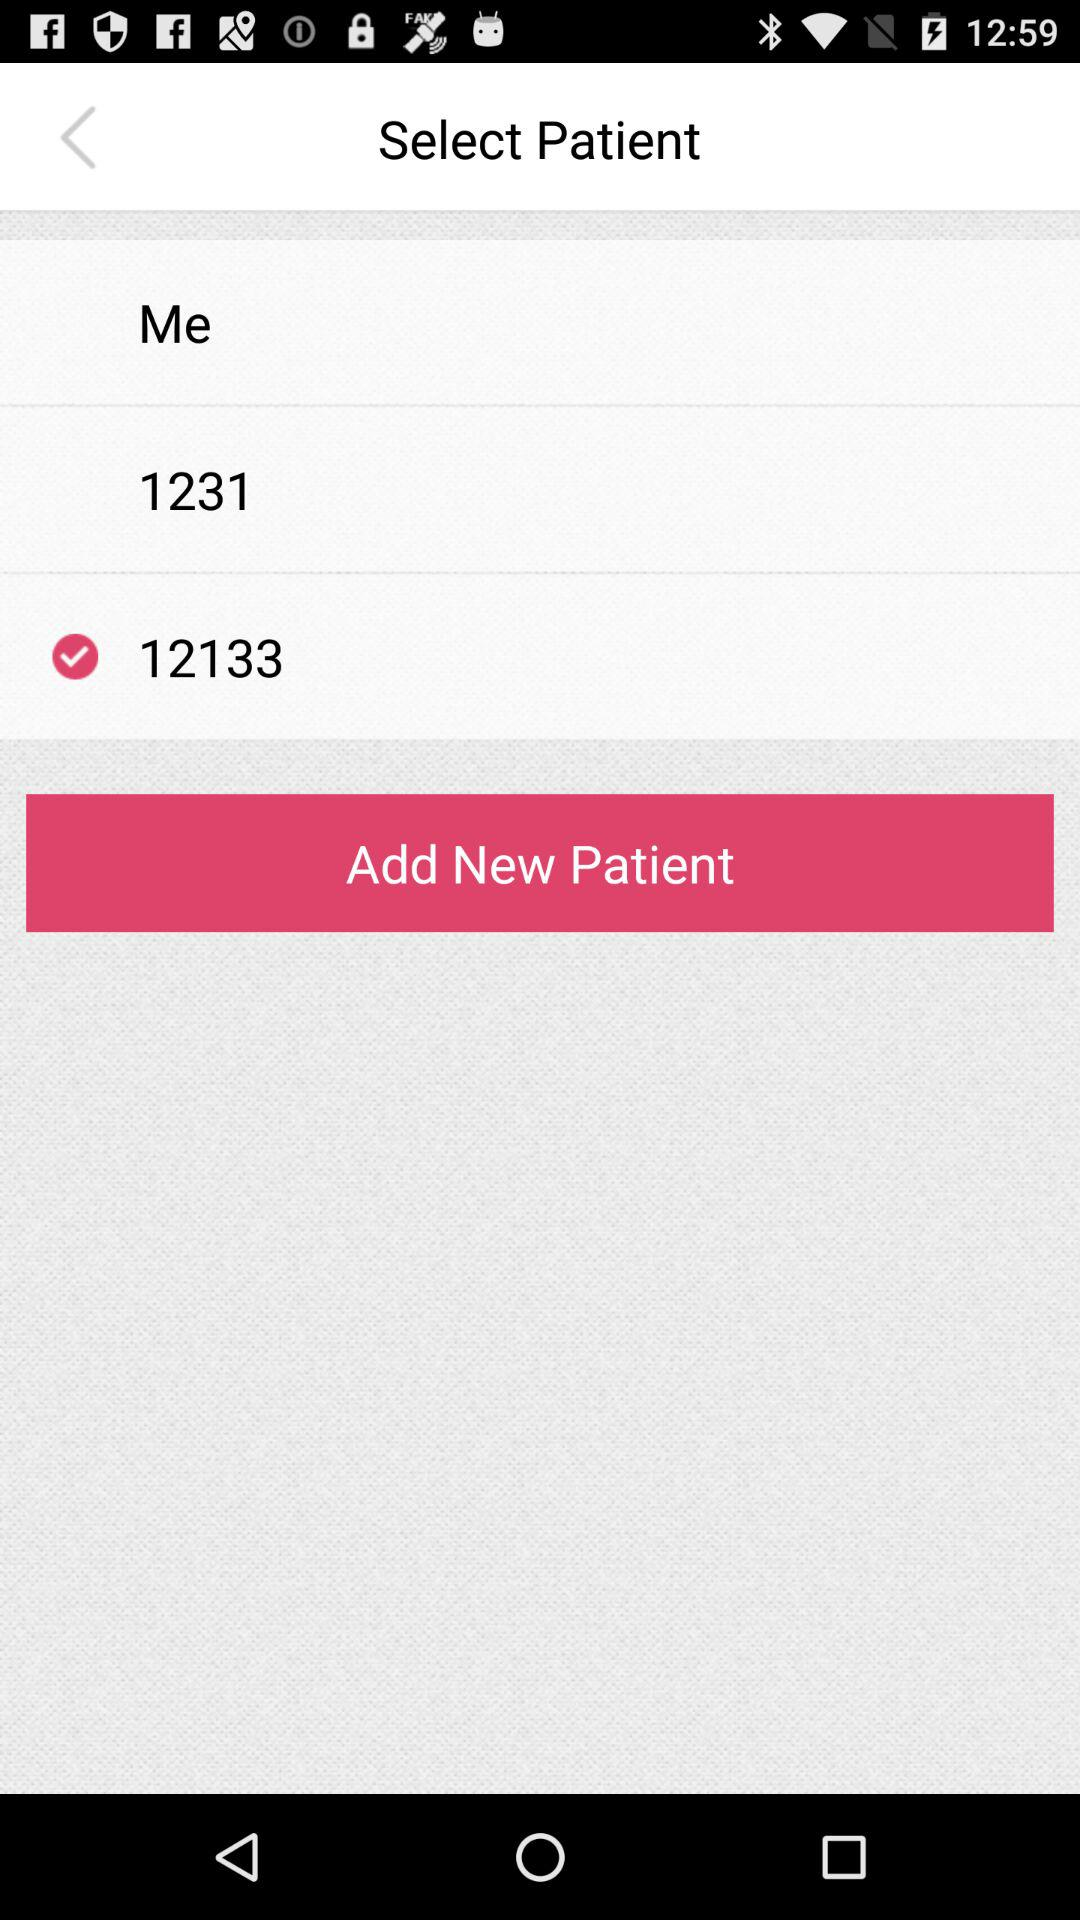How many patients are not currently selected?
Answer the question using a single word or phrase. 2 